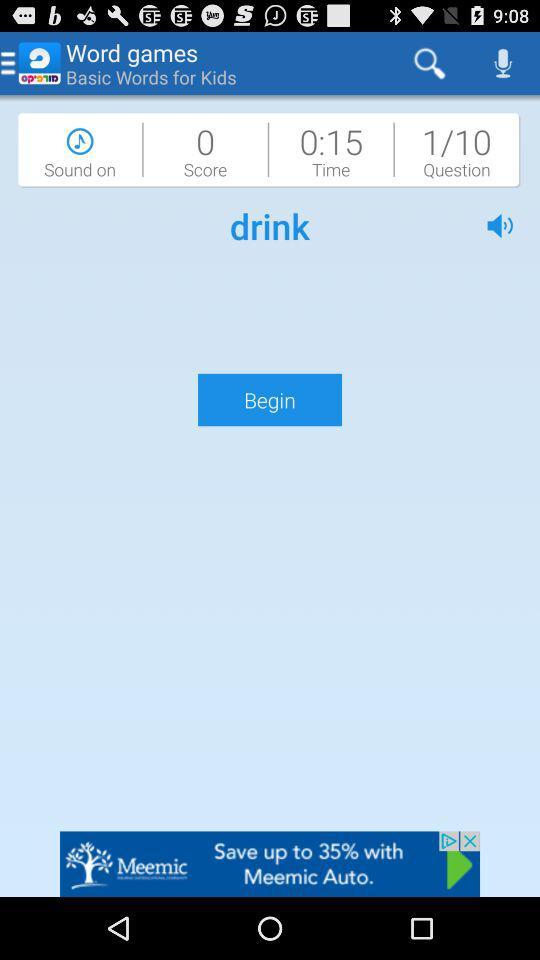What is the score? The score is 0. 